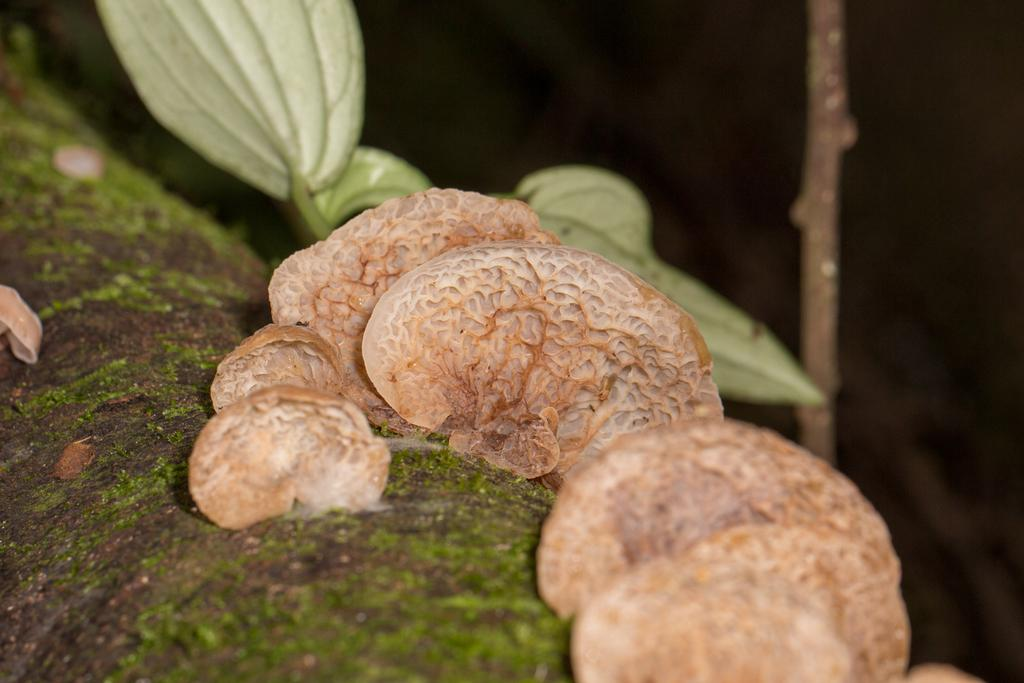What type of fungi can be seen on the ground in the image? There are mushrooms on the ground in the image. What other natural elements are present near the mushrooms? There are leaves beside the mushrooms in the image. What color is the sweater worn by the mushroom in the image? There is no sweater present in the image, as mushrooms do not wear clothing. 